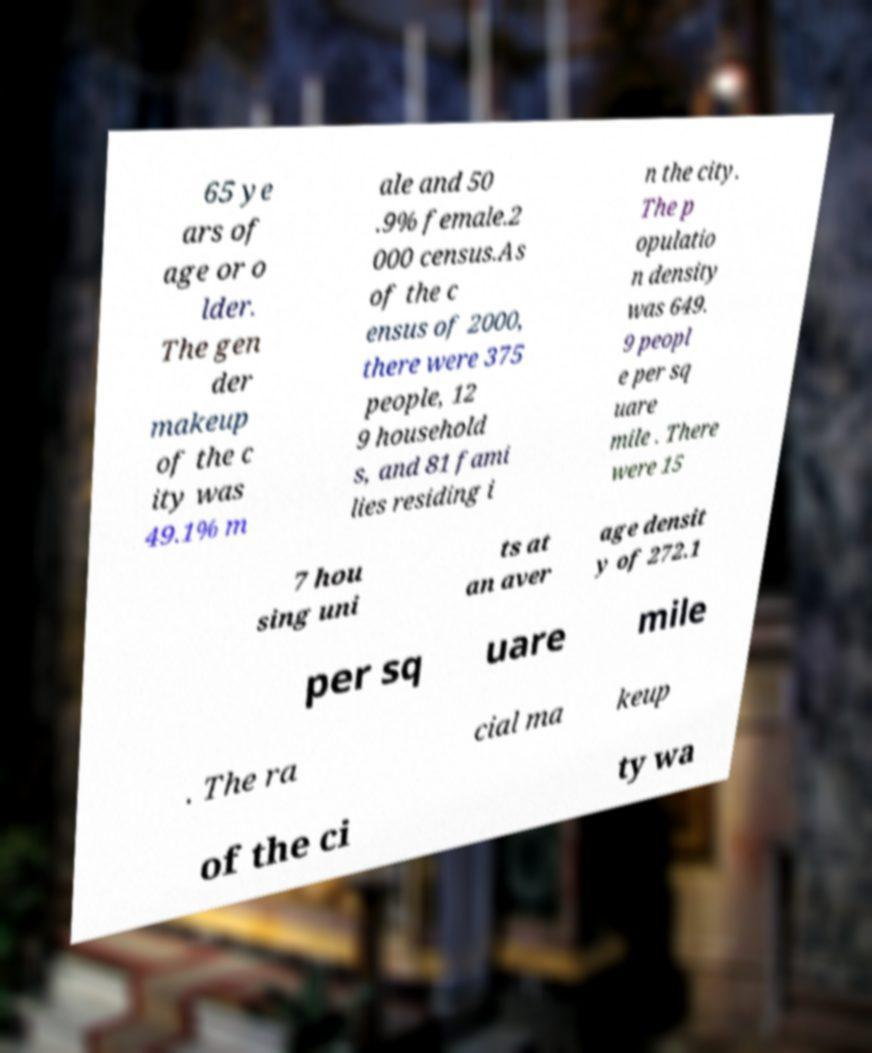I need the written content from this picture converted into text. Can you do that? 65 ye ars of age or o lder. The gen der makeup of the c ity was 49.1% m ale and 50 .9% female.2 000 census.As of the c ensus of 2000, there were 375 people, 12 9 household s, and 81 fami lies residing i n the city. The p opulatio n density was 649. 9 peopl e per sq uare mile . There were 15 7 hou sing uni ts at an aver age densit y of 272.1 per sq uare mile . The ra cial ma keup of the ci ty wa 